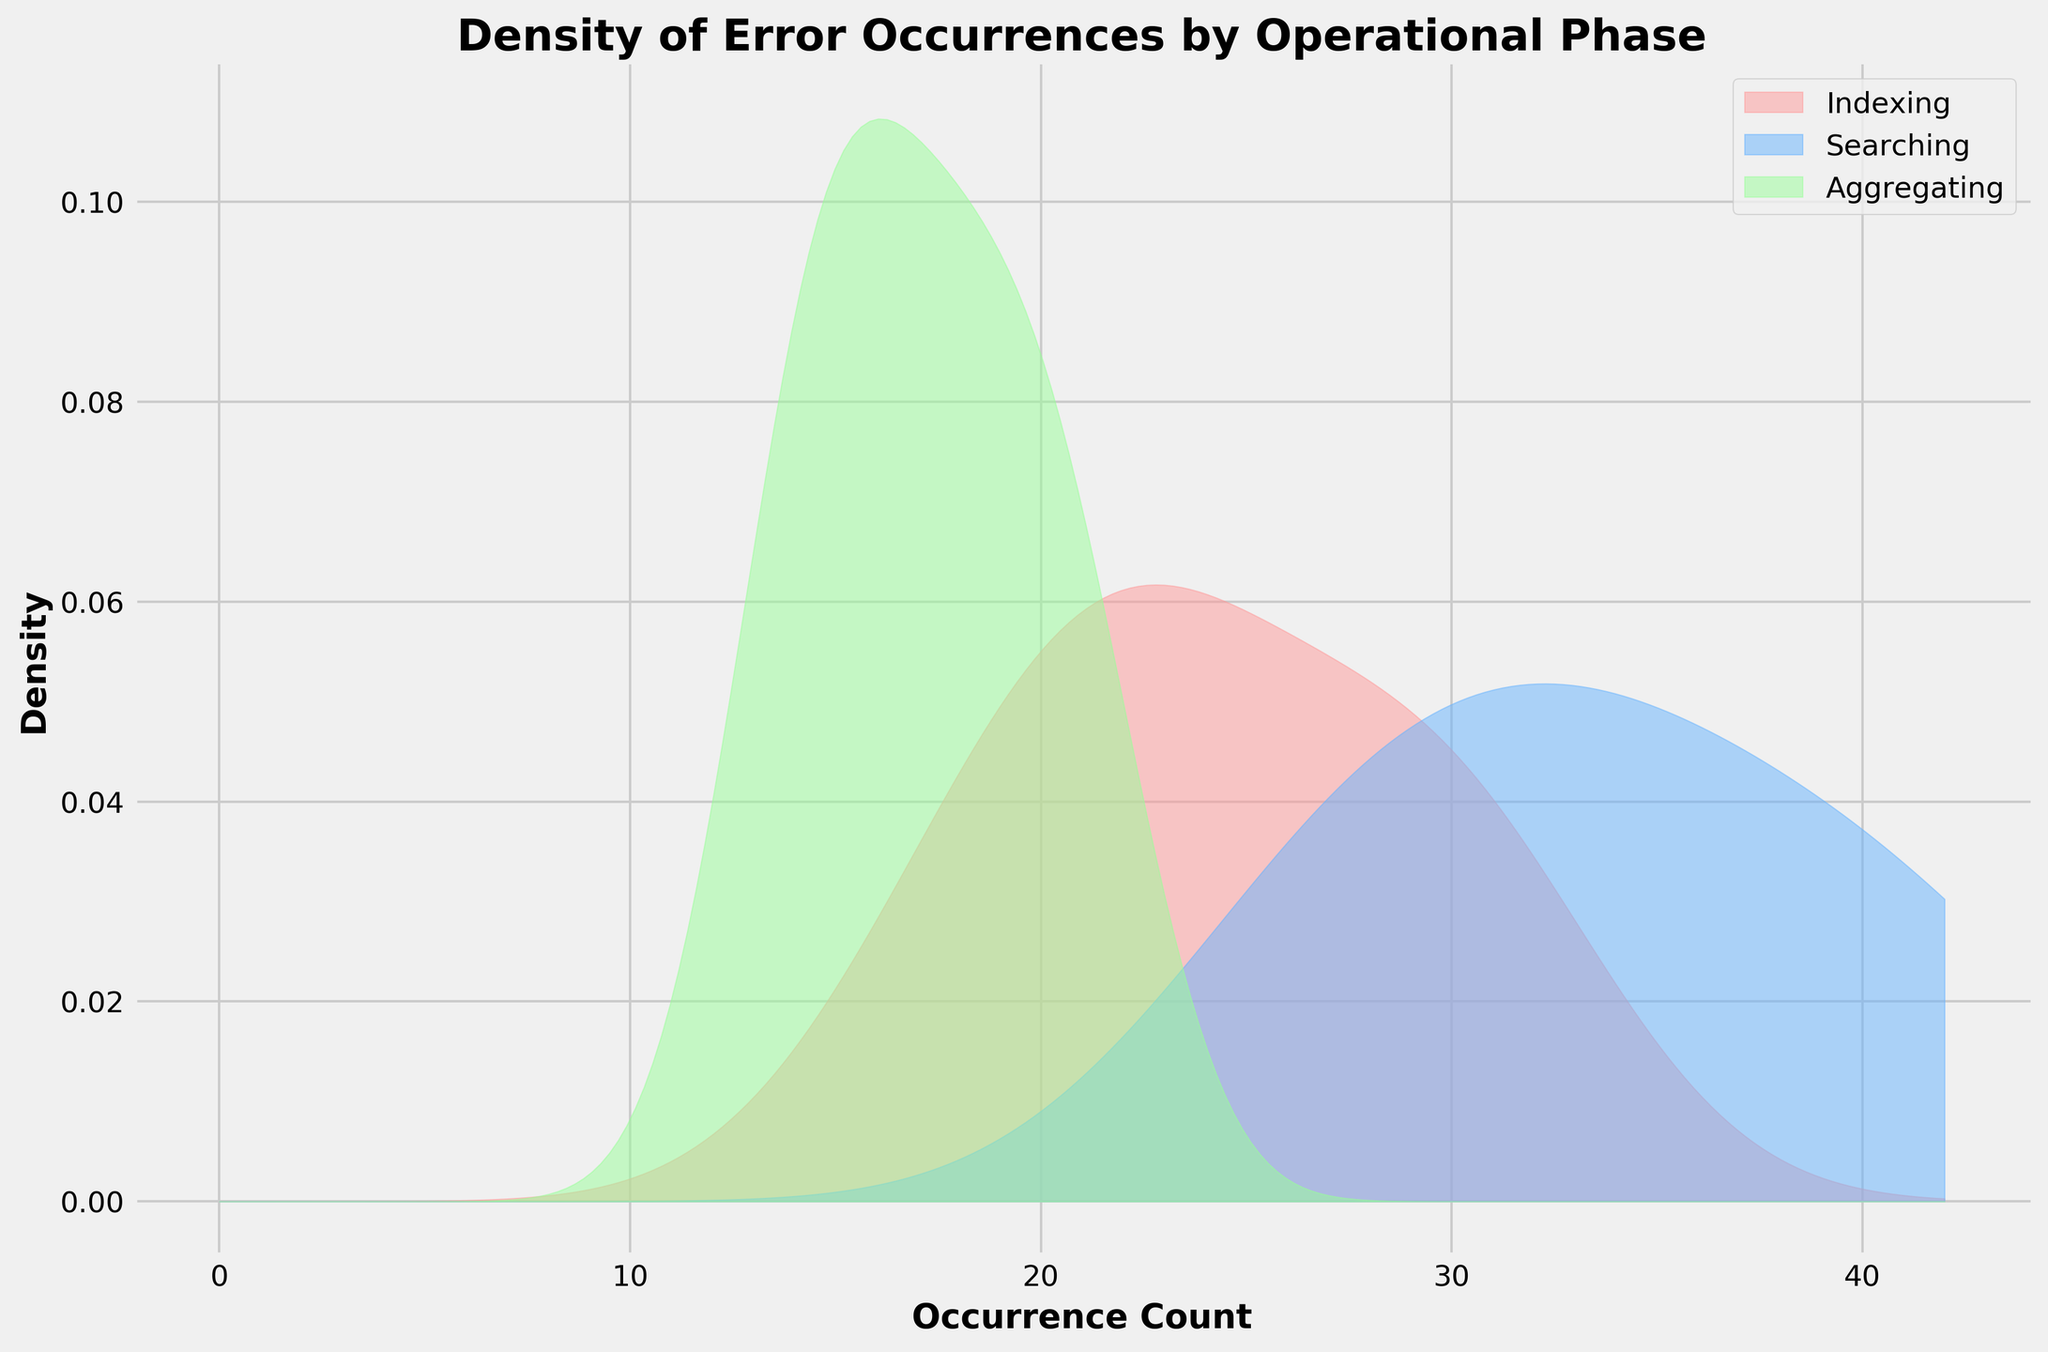What is the title of the density plot? The title of the plot is clearly indicated at the top.
Answer: Density of Error Occurrences by Operational Phase How many operational phases are represented in the plot? By examining the legend or the density plot colors, we can see that there are three distinct operational phases.
Answer: Three What colors are used to represent the different operational phases? By referring to the legend and the different areas filled under the density curves, we observe three colors: red, blue, and green.
Answer: Red, Blue, Green Which operational phase has the highest density peak? By looking at the highest point of the density curves, the 'Searching' phase, represented by blue, has the highest density peak.
Answer: Searching What is the range of Occurrence Counts shown on the x-axis? The x-axis starts from 0 and extends to the maximum value shown on the plot, which based on the density curves, seems to end around 50.
Answer: 0 to 50 Between which Occurrence Counts does the 'Indexing' phase show its highest density? The reddest peak position can be visually identified to fall between 20 and 30 on the x-axis.
Answer: 20 to 30 Which operational phase has the lowest maximum density value? By comparing the peaks of the density curves, the 'Aggregating' phase, represented by green, has the lowest maximum density value.
Answer: Aggregating What is the approximate Occurrence Count where the 'Searching' phase has a notable increasing trend? Observing the blue curve rising sharply, it starts increasing notably around an Occurrence Count of 20.
Answer: 20 What phase shows a density trend suggesting a secondary mode? The 'Aggregating' phase, shown by the green density curve, appears to have a minor second peak suggesting a secondary mode.
Answer: Aggregating How does the 'Searching' phase density curve compare to the 'Indexing' phase density curve around the Occurrence Count of 35? By comparing the blue and red curves at the Occurrence Count of 35, the 'Searching' phase's density is higher than the 'Indexing' phase.
Answer: Searching phase's density is higher 